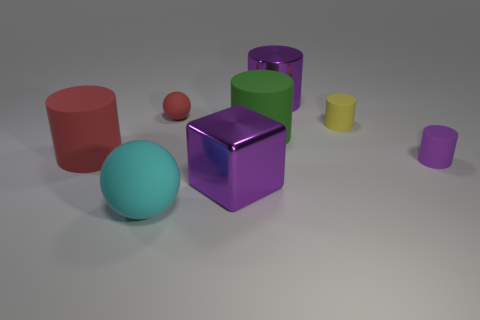Subtract 2 cylinders. How many cylinders are left? 3 Subtract all green cylinders. How many cylinders are left? 4 Subtract all cyan cylinders. Subtract all blue balls. How many cylinders are left? 5 Add 2 purple metallic cylinders. How many objects exist? 10 Subtract all balls. How many objects are left? 6 Subtract 0 cyan blocks. How many objects are left? 8 Subtract all red spheres. Subtract all purple objects. How many objects are left? 4 Add 6 small matte balls. How many small matte balls are left? 7 Add 8 green cylinders. How many green cylinders exist? 9 